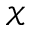<formula> <loc_0><loc_0><loc_500><loc_500>\mathcal { X }</formula> 